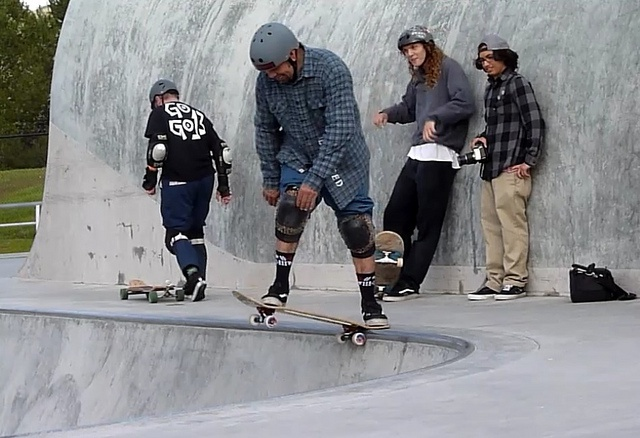Describe the objects in this image and their specific colors. I can see people in darkgreen, black, gray, and darkgray tones, people in darkgreen, black, gray, darkgray, and lavender tones, people in darkgreen, black, gray, and darkgray tones, people in darkgreen, black, gray, white, and darkgray tones, and skateboard in darkgreen, darkgray, gray, black, and lightgray tones in this image. 